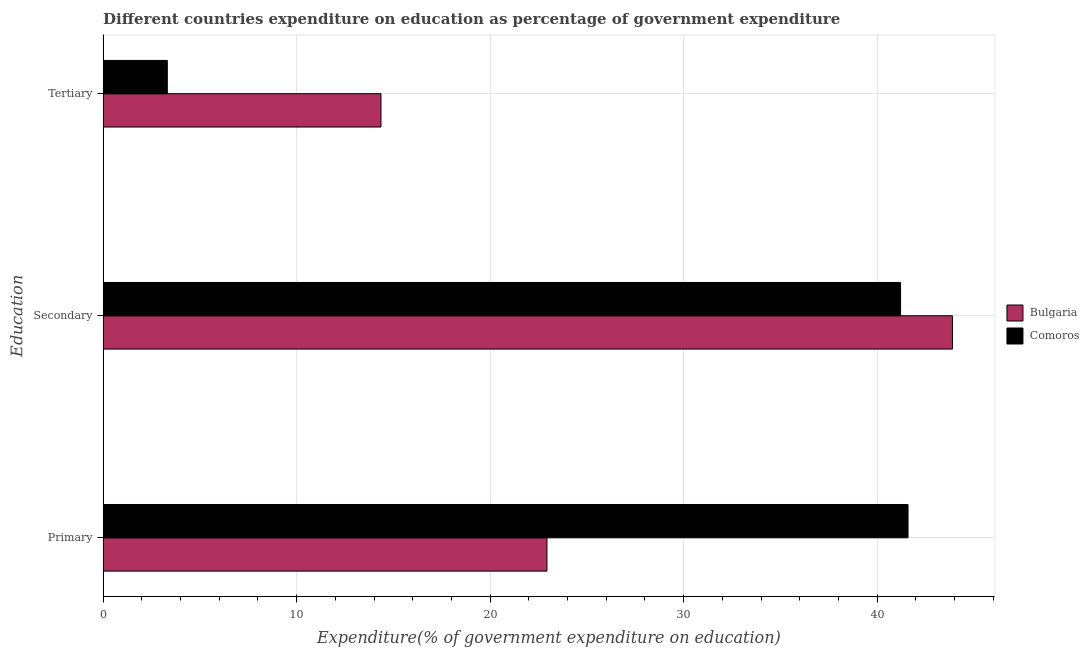How many different coloured bars are there?
Provide a succinct answer. 2. What is the label of the 1st group of bars from the top?
Offer a very short reply. Tertiary. What is the expenditure on secondary education in Comoros?
Ensure brevity in your answer.  41.21. Across all countries, what is the maximum expenditure on tertiary education?
Make the answer very short. 14.36. Across all countries, what is the minimum expenditure on secondary education?
Make the answer very short. 41.21. In which country was the expenditure on primary education maximum?
Your response must be concise. Comoros. In which country was the expenditure on primary education minimum?
Your answer should be very brief. Bulgaria. What is the total expenditure on primary education in the graph?
Give a very brief answer. 64.54. What is the difference between the expenditure on secondary education in Comoros and that in Bulgaria?
Your answer should be compact. -2.68. What is the difference between the expenditure on tertiary education in Bulgaria and the expenditure on secondary education in Comoros?
Offer a terse response. -26.85. What is the average expenditure on tertiary education per country?
Your answer should be compact. 8.84. What is the difference between the expenditure on secondary education and expenditure on primary education in Bulgaria?
Provide a succinct answer. 20.96. What is the ratio of the expenditure on secondary education in Comoros to that in Bulgaria?
Keep it short and to the point. 0.94. Is the difference between the expenditure on tertiary education in Bulgaria and Comoros greater than the difference between the expenditure on secondary education in Bulgaria and Comoros?
Offer a terse response. Yes. What is the difference between the highest and the second highest expenditure on secondary education?
Give a very brief answer. 2.68. What is the difference between the highest and the lowest expenditure on primary education?
Provide a succinct answer. 18.66. Is the sum of the expenditure on secondary education in Bulgaria and Comoros greater than the maximum expenditure on tertiary education across all countries?
Ensure brevity in your answer.  Yes. What does the 1st bar from the top in Secondary represents?
Offer a very short reply. Comoros. What does the 1st bar from the bottom in Tertiary represents?
Make the answer very short. Bulgaria. Are all the bars in the graph horizontal?
Keep it short and to the point. Yes. How many countries are there in the graph?
Give a very brief answer. 2. Where does the legend appear in the graph?
Your answer should be very brief. Center right. How many legend labels are there?
Make the answer very short. 2. How are the legend labels stacked?
Your response must be concise. Vertical. What is the title of the graph?
Your answer should be compact. Different countries expenditure on education as percentage of government expenditure. Does "Niger" appear as one of the legend labels in the graph?
Make the answer very short. No. What is the label or title of the X-axis?
Offer a very short reply. Expenditure(% of government expenditure on education). What is the label or title of the Y-axis?
Your response must be concise. Education. What is the Expenditure(% of government expenditure on education) of Bulgaria in Primary?
Your answer should be compact. 22.94. What is the Expenditure(% of government expenditure on education) in Comoros in Primary?
Make the answer very short. 41.6. What is the Expenditure(% of government expenditure on education) in Bulgaria in Secondary?
Provide a short and direct response. 43.9. What is the Expenditure(% of government expenditure on education) in Comoros in Secondary?
Offer a terse response. 41.21. What is the Expenditure(% of government expenditure on education) of Bulgaria in Tertiary?
Keep it short and to the point. 14.36. What is the Expenditure(% of government expenditure on education) of Comoros in Tertiary?
Ensure brevity in your answer.  3.32. Across all Education, what is the maximum Expenditure(% of government expenditure on education) in Bulgaria?
Your answer should be compact. 43.9. Across all Education, what is the maximum Expenditure(% of government expenditure on education) in Comoros?
Give a very brief answer. 41.6. Across all Education, what is the minimum Expenditure(% of government expenditure on education) of Bulgaria?
Your answer should be very brief. 14.36. Across all Education, what is the minimum Expenditure(% of government expenditure on education) of Comoros?
Your response must be concise. 3.32. What is the total Expenditure(% of government expenditure on education) in Bulgaria in the graph?
Provide a succinct answer. 81.19. What is the total Expenditure(% of government expenditure on education) of Comoros in the graph?
Your answer should be compact. 86.13. What is the difference between the Expenditure(% of government expenditure on education) of Bulgaria in Primary and that in Secondary?
Your response must be concise. -20.96. What is the difference between the Expenditure(% of government expenditure on education) in Comoros in Primary and that in Secondary?
Your answer should be compact. 0.39. What is the difference between the Expenditure(% of government expenditure on education) of Bulgaria in Primary and that in Tertiary?
Provide a short and direct response. 8.58. What is the difference between the Expenditure(% of government expenditure on education) in Comoros in Primary and that in Tertiary?
Provide a short and direct response. 38.28. What is the difference between the Expenditure(% of government expenditure on education) of Bulgaria in Secondary and that in Tertiary?
Provide a short and direct response. 29.54. What is the difference between the Expenditure(% of government expenditure on education) of Comoros in Secondary and that in Tertiary?
Your answer should be very brief. 37.9. What is the difference between the Expenditure(% of government expenditure on education) of Bulgaria in Primary and the Expenditure(% of government expenditure on education) of Comoros in Secondary?
Provide a succinct answer. -18.28. What is the difference between the Expenditure(% of government expenditure on education) in Bulgaria in Primary and the Expenditure(% of government expenditure on education) in Comoros in Tertiary?
Offer a very short reply. 19.62. What is the difference between the Expenditure(% of government expenditure on education) of Bulgaria in Secondary and the Expenditure(% of government expenditure on education) of Comoros in Tertiary?
Your response must be concise. 40.58. What is the average Expenditure(% of government expenditure on education) in Bulgaria per Education?
Provide a succinct answer. 27.06. What is the average Expenditure(% of government expenditure on education) of Comoros per Education?
Provide a short and direct response. 28.71. What is the difference between the Expenditure(% of government expenditure on education) of Bulgaria and Expenditure(% of government expenditure on education) of Comoros in Primary?
Keep it short and to the point. -18.66. What is the difference between the Expenditure(% of government expenditure on education) of Bulgaria and Expenditure(% of government expenditure on education) of Comoros in Secondary?
Offer a terse response. 2.68. What is the difference between the Expenditure(% of government expenditure on education) of Bulgaria and Expenditure(% of government expenditure on education) of Comoros in Tertiary?
Offer a terse response. 11.04. What is the ratio of the Expenditure(% of government expenditure on education) in Bulgaria in Primary to that in Secondary?
Ensure brevity in your answer.  0.52. What is the ratio of the Expenditure(% of government expenditure on education) of Comoros in Primary to that in Secondary?
Keep it short and to the point. 1.01. What is the ratio of the Expenditure(% of government expenditure on education) of Bulgaria in Primary to that in Tertiary?
Give a very brief answer. 1.6. What is the ratio of the Expenditure(% of government expenditure on education) in Comoros in Primary to that in Tertiary?
Provide a succinct answer. 12.54. What is the ratio of the Expenditure(% of government expenditure on education) of Bulgaria in Secondary to that in Tertiary?
Your answer should be compact. 3.06. What is the ratio of the Expenditure(% of government expenditure on education) in Comoros in Secondary to that in Tertiary?
Keep it short and to the point. 12.42. What is the difference between the highest and the second highest Expenditure(% of government expenditure on education) of Bulgaria?
Make the answer very short. 20.96. What is the difference between the highest and the second highest Expenditure(% of government expenditure on education) in Comoros?
Offer a very short reply. 0.39. What is the difference between the highest and the lowest Expenditure(% of government expenditure on education) of Bulgaria?
Your answer should be compact. 29.54. What is the difference between the highest and the lowest Expenditure(% of government expenditure on education) of Comoros?
Your answer should be compact. 38.28. 